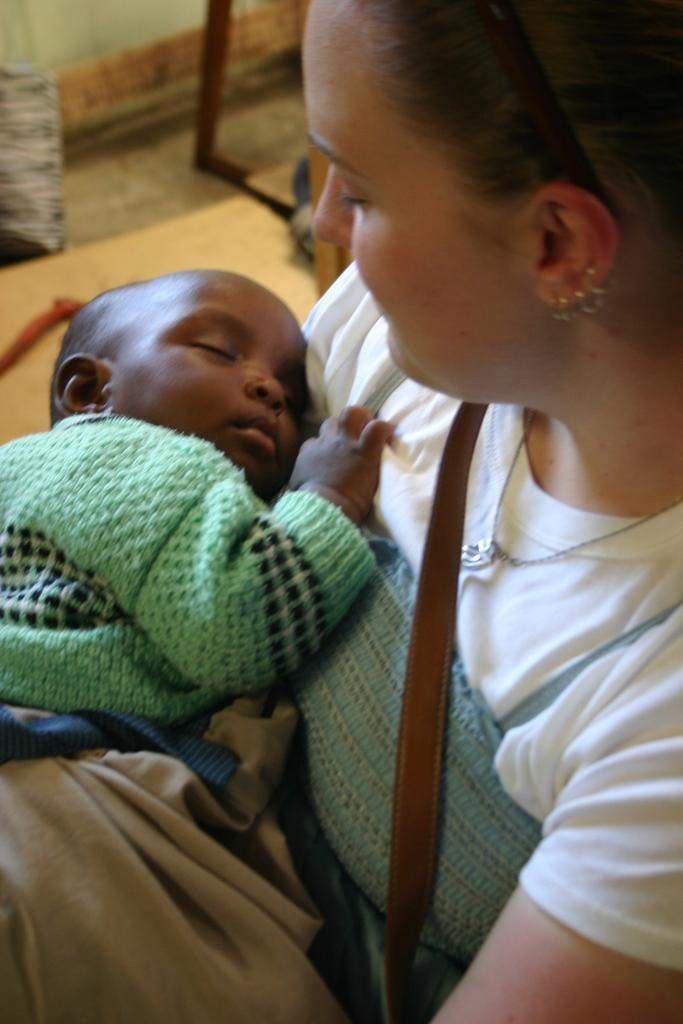How many people are in the image? There are two persons in the image. What is the baby doing in the image? A baby is sleeping in the image. What can be seen on the floor in the image? There are objects on the floor in the image. Where is the toothbrush located in the image? There is no toothbrush present in the image. What type of kitty can be seen playing with the baby in the image? There is no kitty present in the image. 